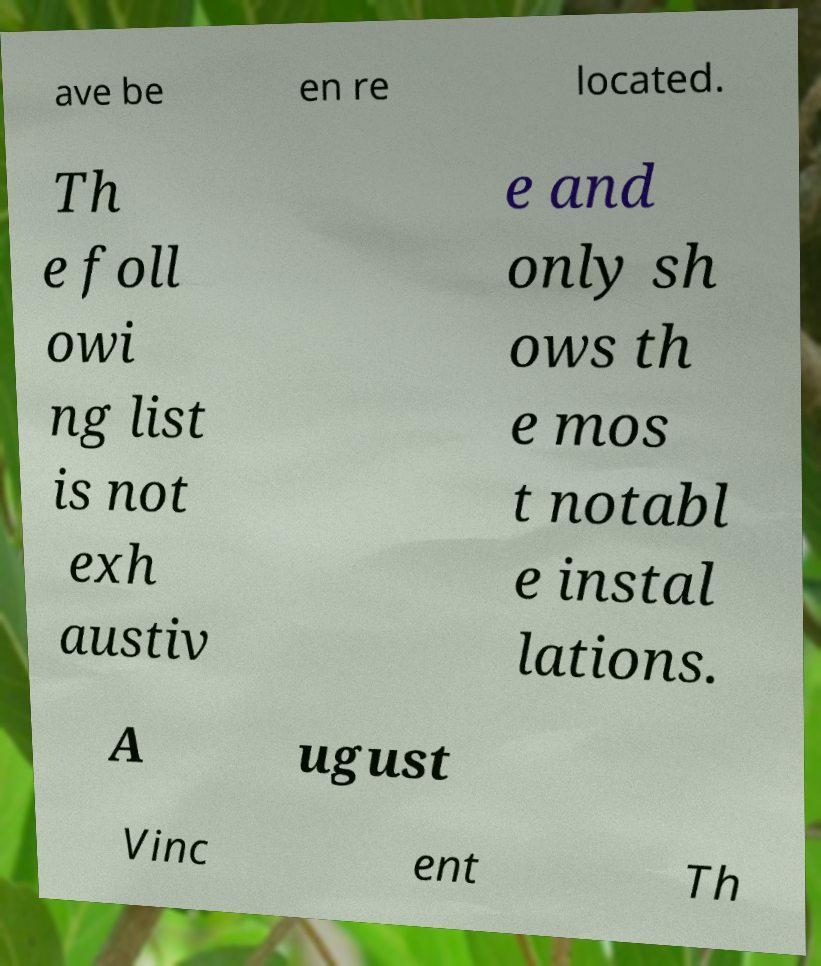For documentation purposes, I need the text within this image transcribed. Could you provide that? ave be en re located. Th e foll owi ng list is not exh austiv e and only sh ows th e mos t notabl e instal lations. A ugust Vinc ent Th 